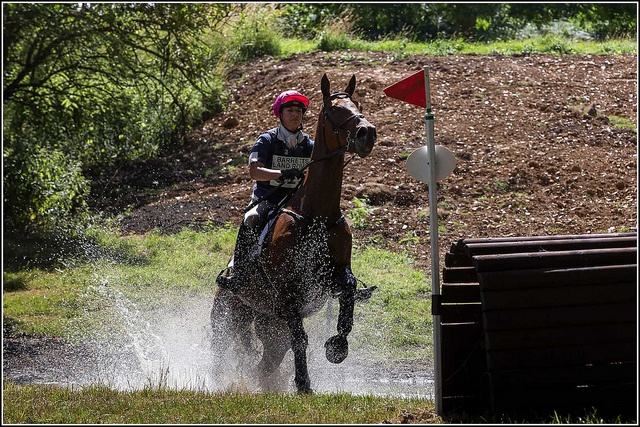Describe the objects in this image and their specific colors. I can see horse in black, gray, and darkgray tones and people in black, gray, maroon, and white tones in this image. 